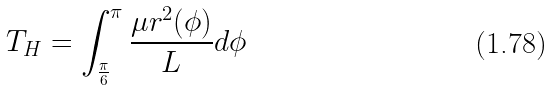<formula> <loc_0><loc_0><loc_500><loc_500>T _ { H } = \int _ { \frac { \pi } { 6 } } ^ { \pi } \frac { \mu r ^ { 2 } ( \phi ) } { L } d \phi</formula> 